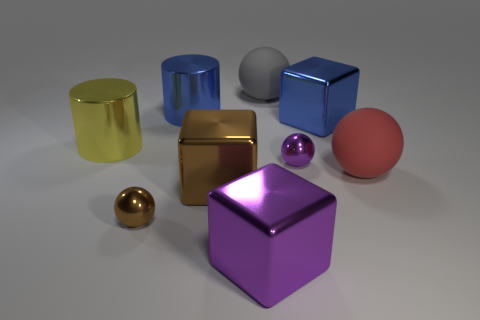What could be the approximate size of these objects? Given their portrayal in the image, the objects might resemble common sizes, with spheres around 5-10 centimeters in diameter, and cubes likely ranging from about 7-12 centimeters per side. 